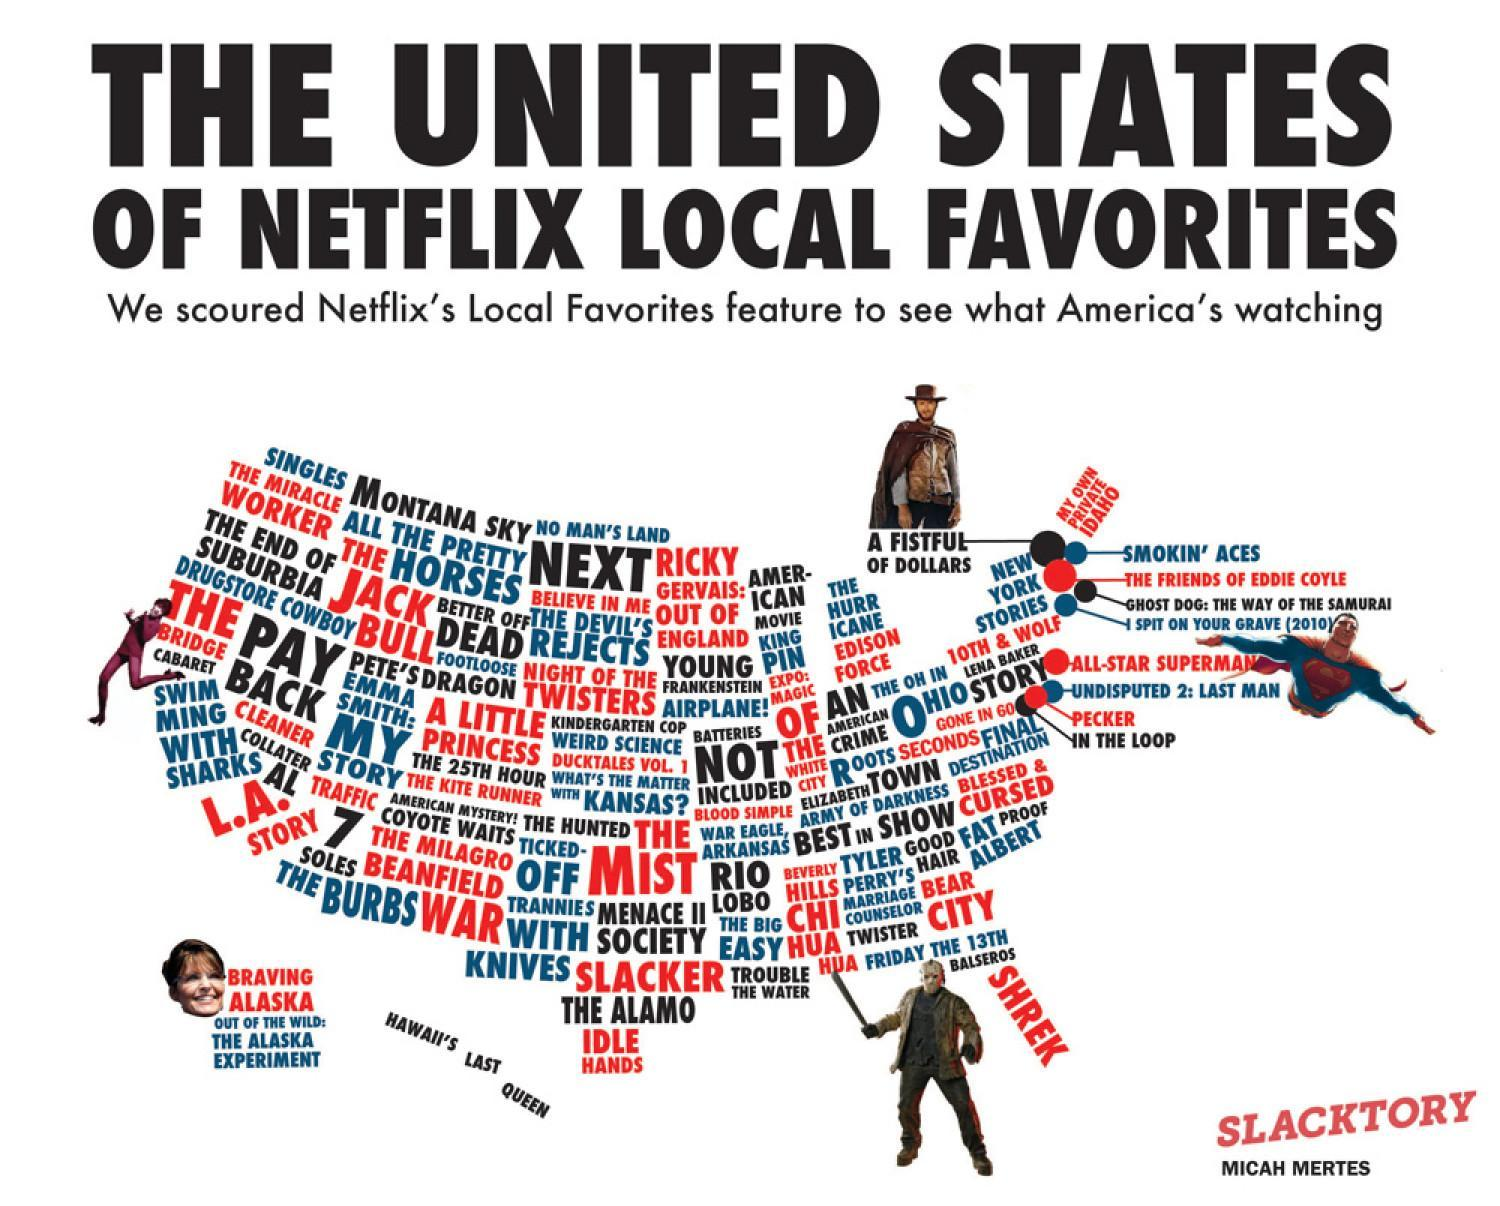what is the text colour for SHREK, white, black, red
Answer the question with a short phrase. red what is the year written next to superman 2010 